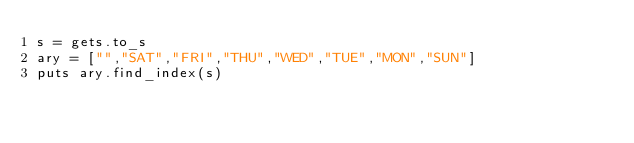Convert code to text. <code><loc_0><loc_0><loc_500><loc_500><_Ruby_>s = gets.to_s
ary = ["","SAT","FRI","THU","WED","TUE","MON","SUN"]
puts ary.find_index(s)</code> 